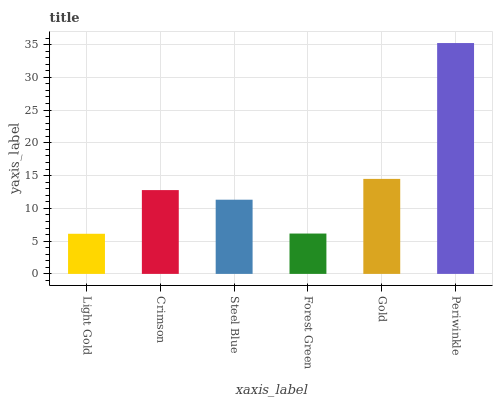Is Light Gold the minimum?
Answer yes or no. Yes. Is Periwinkle the maximum?
Answer yes or no. Yes. Is Crimson the minimum?
Answer yes or no. No. Is Crimson the maximum?
Answer yes or no. No. Is Crimson greater than Light Gold?
Answer yes or no. Yes. Is Light Gold less than Crimson?
Answer yes or no. Yes. Is Light Gold greater than Crimson?
Answer yes or no. No. Is Crimson less than Light Gold?
Answer yes or no. No. Is Crimson the high median?
Answer yes or no. Yes. Is Steel Blue the low median?
Answer yes or no. Yes. Is Steel Blue the high median?
Answer yes or no. No. Is Periwinkle the low median?
Answer yes or no. No. 